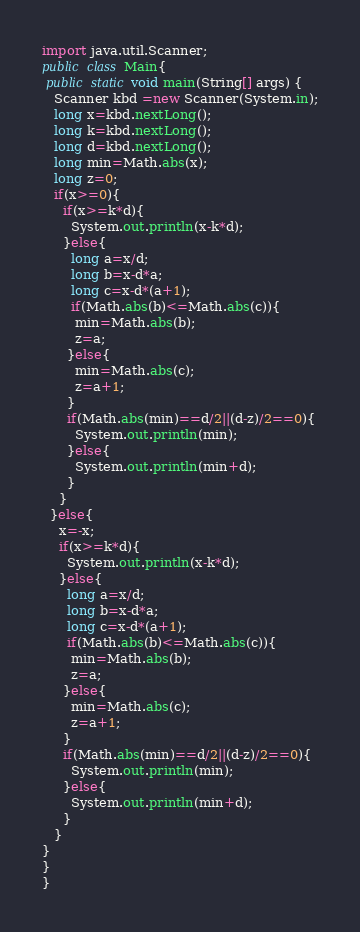<code> <loc_0><loc_0><loc_500><loc_500><_Java_>import java.util.Scanner;
public class Main{
 public static void main(String[] args) {
   Scanner kbd =new Scanner(System.in);
   long x=kbd.nextLong();
   long k=kbd.nextLong();
   long d=kbd.nextLong();
   long min=Math.abs(x);
   long z=0;
   if(x>=0){
     if(x>=k*d){
       System.out.println(x-k*d);
     }else{
       long a=x/d;
       long b=x-d*a;
       long c=x-d*(a+1);
       if(Math.abs(b)<=Math.abs(c)){
        min=Math.abs(b);
        z=a;
      }else{
        min=Math.abs(c);
        z=a+1;
      }
      if(Math.abs(min)==d/2||(d-z)/2==0){
        System.out.println(min);
      }else{
        System.out.println(min+d);
      }
    }
  }else{
    x=-x;
    if(x>=k*d){
      System.out.println(x-k*d);
    }else{
      long a=x/d;
      long b=x-d*a;
      long c=x-d*(a+1);
      if(Math.abs(b)<=Math.abs(c)){
       min=Math.abs(b);
       z=a;
     }else{
       min=Math.abs(c);
       z=a+1;
     }
     if(Math.abs(min)==d/2||(d-z)/2==0){
       System.out.println(min);
     }else{
       System.out.println(min+d);
     }
   }
}
}
}</code> 